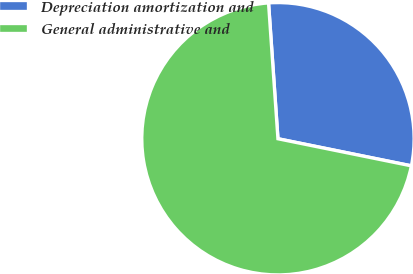Convert chart. <chart><loc_0><loc_0><loc_500><loc_500><pie_chart><fcel>Depreciation amortization and<fcel>General administrative and<nl><fcel>29.29%<fcel>70.71%<nl></chart> 